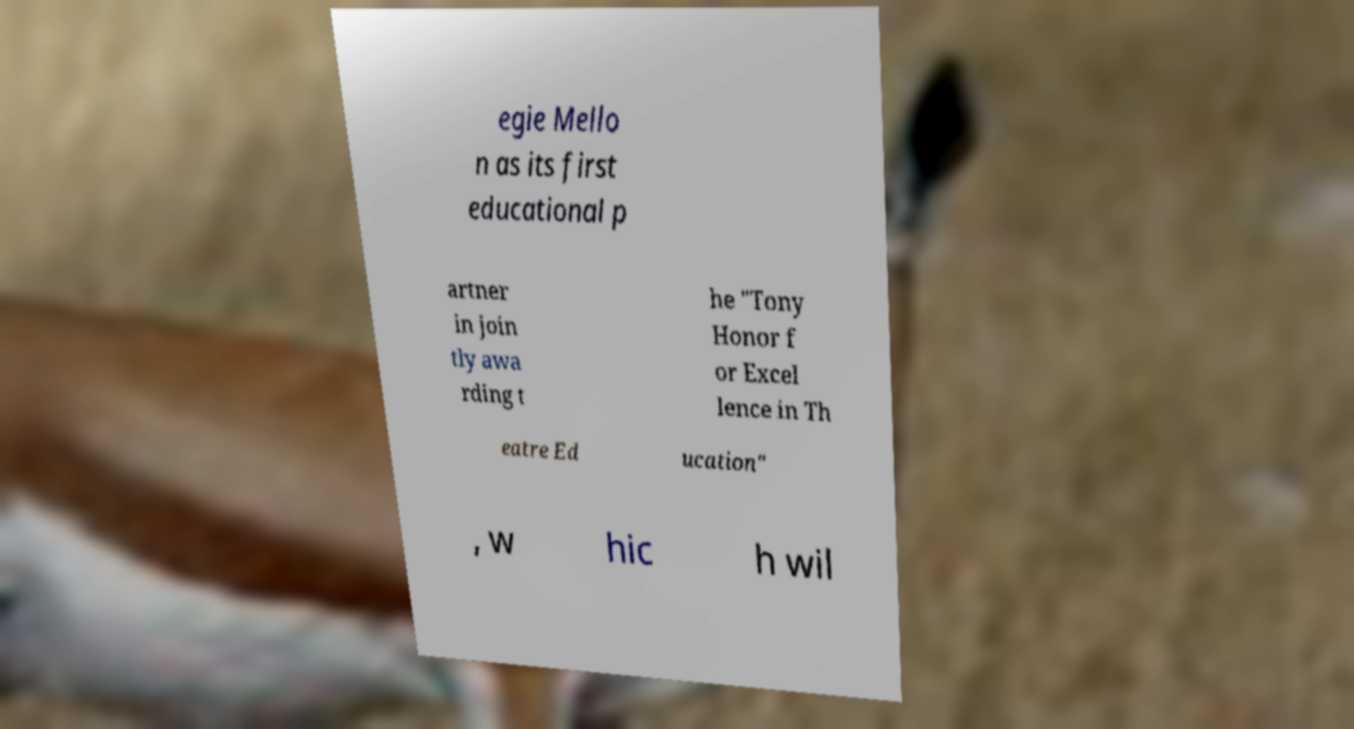I need the written content from this picture converted into text. Can you do that? egie Mello n as its first educational p artner in join tly awa rding t he "Tony Honor f or Excel lence in Th eatre Ed ucation" , w hic h wil 